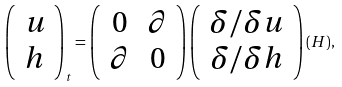<formula> <loc_0><loc_0><loc_500><loc_500>\left ( \begin{array} { c } u \\ h \end{array} \right ) _ { t } = \left ( \begin{array} { c c } 0 & \partial \\ \partial & 0 \end{array} \right ) \left ( \begin{array} { c } \delta / \delta u \\ \delta / \delta h \end{array} \right ) ( H ) ,</formula> 